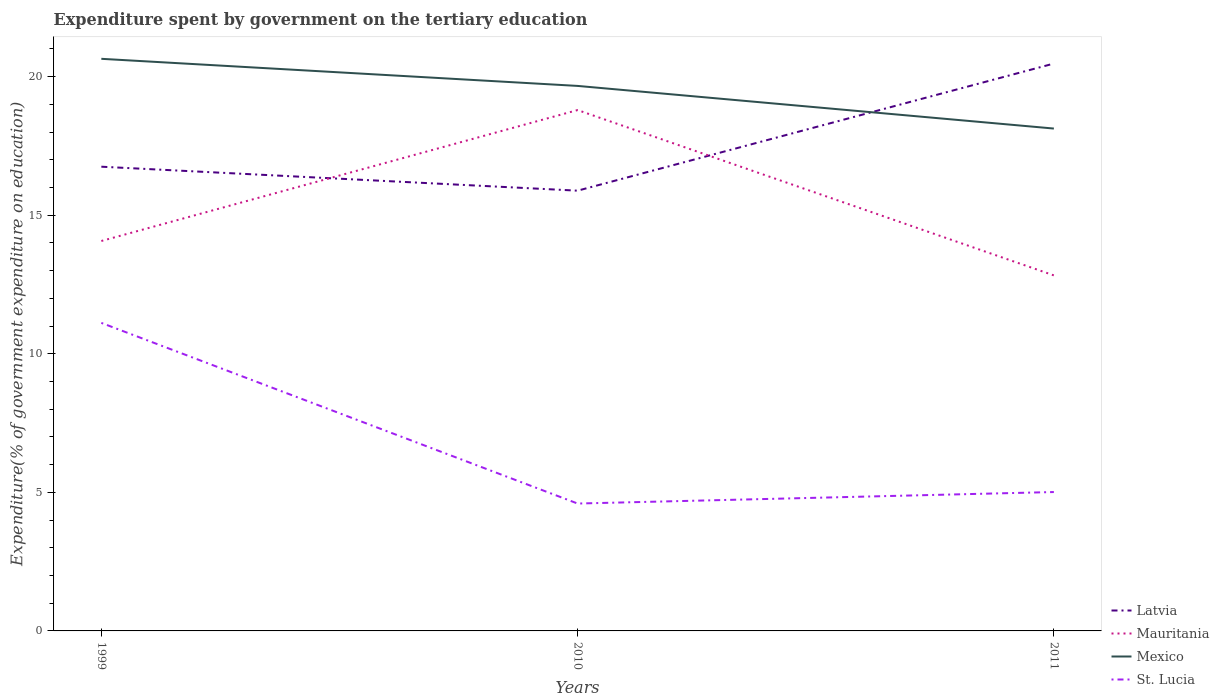Across all years, what is the maximum expenditure spent by government on the tertiary education in Latvia?
Offer a very short reply. 15.88. In which year was the expenditure spent by government on the tertiary education in Latvia maximum?
Make the answer very short. 2010. What is the total expenditure spent by government on the tertiary education in Latvia in the graph?
Provide a short and direct response. 0.86. What is the difference between the highest and the second highest expenditure spent by government on the tertiary education in Mexico?
Your answer should be very brief. 2.52. How many years are there in the graph?
Give a very brief answer. 3. Does the graph contain any zero values?
Your response must be concise. No. Does the graph contain grids?
Your answer should be very brief. No. Where does the legend appear in the graph?
Your response must be concise. Bottom right. How many legend labels are there?
Ensure brevity in your answer.  4. What is the title of the graph?
Your answer should be very brief. Expenditure spent by government on the tertiary education. Does "Sub-Saharan Africa (all income levels)" appear as one of the legend labels in the graph?
Provide a succinct answer. No. What is the label or title of the Y-axis?
Offer a terse response. Expenditure(% of government expenditure on education). What is the Expenditure(% of government expenditure on education) in Latvia in 1999?
Offer a terse response. 16.75. What is the Expenditure(% of government expenditure on education) of Mauritania in 1999?
Your answer should be very brief. 14.07. What is the Expenditure(% of government expenditure on education) of Mexico in 1999?
Your answer should be very brief. 20.64. What is the Expenditure(% of government expenditure on education) in St. Lucia in 1999?
Provide a succinct answer. 11.11. What is the Expenditure(% of government expenditure on education) in Latvia in 2010?
Your answer should be compact. 15.88. What is the Expenditure(% of government expenditure on education) of Mauritania in 2010?
Offer a very short reply. 18.79. What is the Expenditure(% of government expenditure on education) of Mexico in 2010?
Provide a succinct answer. 19.66. What is the Expenditure(% of government expenditure on education) of St. Lucia in 2010?
Give a very brief answer. 4.6. What is the Expenditure(% of government expenditure on education) of Latvia in 2011?
Your answer should be very brief. 20.47. What is the Expenditure(% of government expenditure on education) of Mauritania in 2011?
Make the answer very short. 12.83. What is the Expenditure(% of government expenditure on education) of Mexico in 2011?
Offer a terse response. 18.13. What is the Expenditure(% of government expenditure on education) of St. Lucia in 2011?
Offer a terse response. 5.01. Across all years, what is the maximum Expenditure(% of government expenditure on education) in Latvia?
Keep it short and to the point. 20.47. Across all years, what is the maximum Expenditure(% of government expenditure on education) in Mauritania?
Provide a short and direct response. 18.79. Across all years, what is the maximum Expenditure(% of government expenditure on education) in Mexico?
Offer a terse response. 20.64. Across all years, what is the maximum Expenditure(% of government expenditure on education) of St. Lucia?
Provide a short and direct response. 11.11. Across all years, what is the minimum Expenditure(% of government expenditure on education) of Latvia?
Your answer should be compact. 15.88. Across all years, what is the minimum Expenditure(% of government expenditure on education) in Mauritania?
Provide a short and direct response. 12.83. Across all years, what is the minimum Expenditure(% of government expenditure on education) of Mexico?
Your answer should be very brief. 18.13. Across all years, what is the minimum Expenditure(% of government expenditure on education) in St. Lucia?
Keep it short and to the point. 4.6. What is the total Expenditure(% of government expenditure on education) in Latvia in the graph?
Offer a very short reply. 53.1. What is the total Expenditure(% of government expenditure on education) of Mauritania in the graph?
Ensure brevity in your answer.  45.69. What is the total Expenditure(% of government expenditure on education) of Mexico in the graph?
Your answer should be compact. 58.43. What is the total Expenditure(% of government expenditure on education) in St. Lucia in the graph?
Offer a terse response. 20.72. What is the difference between the Expenditure(% of government expenditure on education) of Latvia in 1999 and that in 2010?
Your response must be concise. 0.86. What is the difference between the Expenditure(% of government expenditure on education) of Mauritania in 1999 and that in 2010?
Offer a terse response. -4.72. What is the difference between the Expenditure(% of government expenditure on education) of Mexico in 1999 and that in 2010?
Your answer should be compact. 0.98. What is the difference between the Expenditure(% of government expenditure on education) in St. Lucia in 1999 and that in 2010?
Provide a succinct answer. 6.52. What is the difference between the Expenditure(% of government expenditure on education) of Latvia in 1999 and that in 2011?
Provide a succinct answer. -3.72. What is the difference between the Expenditure(% of government expenditure on education) in Mauritania in 1999 and that in 2011?
Your answer should be compact. 1.24. What is the difference between the Expenditure(% of government expenditure on education) in Mexico in 1999 and that in 2011?
Make the answer very short. 2.52. What is the difference between the Expenditure(% of government expenditure on education) in St. Lucia in 1999 and that in 2011?
Provide a succinct answer. 6.1. What is the difference between the Expenditure(% of government expenditure on education) of Latvia in 2010 and that in 2011?
Make the answer very short. -4.59. What is the difference between the Expenditure(% of government expenditure on education) of Mauritania in 2010 and that in 2011?
Your response must be concise. 5.96. What is the difference between the Expenditure(% of government expenditure on education) of Mexico in 2010 and that in 2011?
Give a very brief answer. 1.54. What is the difference between the Expenditure(% of government expenditure on education) in St. Lucia in 2010 and that in 2011?
Provide a short and direct response. -0.42. What is the difference between the Expenditure(% of government expenditure on education) in Latvia in 1999 and the Expenditure(% of government expenditure on education) in Mauritania in 2010?
Keep it short and to the point. -2.04. What is the difference between the Expenditure(% of government expenditure on education) in Latvia in 1999 and the Expenditure(% of government expenditure on education) in Mexico in 2010?
Offer a terse response. -2.91. What is the difference between the Expenditure(% of government expenditure on education) of Latvia in 1999 and the Expenditure(% of government expenditure on education) of St. Lucia in 2010?
Offer a very short reply. 12.15. What is the difference between the Expenditure(% of government expenditure on education) in Mauritania in 1999 and the Expenditure(% of government expenditure on education) in Mexico in 2010?
Offer a terse response. -5.59. What is the difference between the Expenditure(% of government expenditure on education) of Mauritania in 1999 and the Expenditure(% of government expenditure on education) of St. Lucia in 2010?
Provide a short and direct response. 9.47. What is the difference between the Expenditure(% of government expenditure on education) in Mexico in 1999 and the Expenditure(% of government expenditure on education) in St. Lucia in 2010?
Provide a short and direct response. 16.05. What is the difference between the Expenditure(% of government expenditure on education) of Latvia in 1999 and the Expenditure(% of government expenditure on education) of Mauritania in 2011?
Provide a succinct answer. 3.92. What is the difference between the Expenditure(% of government expenditure on education) in Latvia in 1999 and the Expenditure(% of government expenditure on education) in Mexico in 2011?
Provide a short and direct response. -1.38. What is the difference between the Expenditure(% of government expenditure on education) in Latvia in 1999 and the Expenditure(% of government expenditure on education) in St. Lucia in 2011?
Make the answer very short. 11.74. What is the difference between the Expenditure(% of government expenditure on education) in Mauritania in 1999 and the Expenditure(% of government expenditure on education) in Mexico in 2011?
Your response must be concise. -4.06. What is the difference between the Expenditure(% of government expenditure on education) of Mauritania in 1999 and the Expenditure(% of government expenditure on education) of St. Lucia in 2011?
Ensure brevity in your answer.  9.06. What is the difference between the Expenditure(% of government expenditure on education) of Mexico in 1999 and the Expenditure(% of government expenditure on education) of St. Lucia in 2011?
Give a very brief answer. 15.63. What is the difference between the Expenditure(% of government expenditure on education) of Latvia in 2010 and the Expenditure(% of government expenditure on education) of Mauritania in 2011?
Your response must be concise. 3.06. What is the difference between the Expenditure(% of government expenditure on education) in Latvia in 2010 and the Expenditure(% of government expenditure on education) in Mexico in 2011?
Your answer should be very brief. -2.24. What is the difference between the Expenditure(% of government expenditure on education) in Latvia in 2010 and the Expenditure(% of government expenditure on education) in St. Lucia in 2011?
Give a very brief answer. 10.87. What is the difference between the Expenditure(% of government expenditure on education) in Mauritania in 2010 and the Expenditure(% of government expenditure on education) in Mexico in 2011?
Your response must be concise. 0.67. What is the difference between the Expenditure(% of government expenditure on education) of Mauritania in 2010 and the Expenditure(% of government expenditure on education) of St. Lucia in 2011?
Offer a terse response. 13.78. What is the difference between the Expenditure(% of government expenditure on education) in Mexico in 2010 and the Expenditure(% of government expenditure on education) in St. Lucia in 2011?
Ensure brevity in your answer.  14.65. What is the average Expenditure(% of government expenditure on education) in Latvia per year?
Keep it short and to the point. 17.7. What is the average Expenditure(% of government expenditure on education) in Mauritania per year?
Your answer should be compact. 15.23. What is the average Expenditure(% of government expenditure on education) in Mexico per year?
Make the answer very short. 19.48. What is the average Expenditure(% of government expenditure on education) in St. Lucia per year?
Keep it short and to the point. 6.91. In the year 1999, what is the difference between the Expenditure(% of government expenditure on education) of Latvia and Expenditure(% of government expenditure on education) of Mauritania?
Offer a very short reply. 2.68. In the year 1999, what is the difference between the Expenditure(% of government expenditure on education) in Latvia and Expenditure(% of government expenditure on education) in Mexico?
Offer a terse response. -3.89. In the year 1999, what is the difference between the Expenditure(% of government expenditure on education) of Latvia and Expenditure(% of government expenditure on education) of St. Lucia?
Your answer should be compact. 5.64. In the year 1999, what is the difference between the Expenditure(% of government expenditure on education) in Mauritania and Expenditure(% of government expenditure on education) in Mexico?
Provide a short and direct response. -6.57. In the year 1999, what is the difference between the Expenditure(% of government expenditure on education) in Mauritania and Expenditure(% of government expenditure on education) in St. Lucia?
Your answer should be very brief. 2.95. In the year 1999, what is the difference between the Expenditure(% of government expenditure on education) of Mexico and Expenditure(% of government expenditure on education) of St. Lucia?
Make the answer very short. 9.53. In the year 2010, what is the difference between the Expenditure(% of government expenditure on education) in Latvia and Expenditure(% of government expenditure on education) in Mauritania?
Provide a succinct answer. -2.91. In the year 2010, what is the difference between the Expenditure(% of government expenditure on education) of Latvia and Expenditure(% of government expenditure on education) of Mexico?
Make the answer very short. -3.78. In the year 2010, what is the difference between the Expenditure(% of government expenditure on education) in Latvia and Expenditure(% of government expenditure on education) in St. Lucia?
Your response must be concise. 11.29. In the year 2010, what is the difference between the Expenditure(% of government expenditure on education) in Mauritania and Expenditure(% of government expenditure on education) in Mexico?
Give a very brief answer. -0.87. In the year 2010, what is the difference between the Expenditure(% of government expenditure on education) in Mauritania and Expenditure(% of government expenditure on education) in St. Lucia?
Your answer should be very brief. 14.2. In the year 2010, what is the difference between the Expenditure(% of government expenditure on education) of Mexico and Expenditure(% of government expenditure on education) of St. Lucia?
Give a very brief answer. 15.07. In the year 2011, what is the difference between the Expenditure(% of government expenditure on education) of Latvia and Expenditure(% of government expenditure on education) of Mauritania?
Your answer should be compact. 7.64. In the year 2011, what is the difference between the Expenditure(% of government expenditure on education) of Latvia and Expenditure(% of government expenditure on education) of Mexico?
Make the answer very short. 2.35. In the year 2011, what is the difference between the Expenditure(% of government expenditure on education) in Latvia and Expenditure(% of government expenditure on education) in St. Lucia?
Give a very brief answer. 15.46. In the year 2011, what is the difference between the Expenditure(% of government expenditure on education) in Mauritania and Expenditure(% of government expenditure on education) in Mexico?
Keep it short and to the point. -5.3. In the year 2011, what is the difference between the Expenditure(% of government expenditure on education) of Mauritania and Expenditure(% of government expenditure on education) of St. Lucia?
Offer a very short reply. 7.82. In the year 2011, what is the difference between the Expenditure(% of government expenditure on education) of Mexico and Expenditure(% of government expenditure on education) of St. Lucia?
Your response must be concise. 13.11. What is the ratio of the Expenditure(% of government expenditure on education) in Latvia in 1999 to that in 2010?
Ensure brevity in your answer.  1.05. What is the ratio of the Expenditure(% of government expenditure on education) of Mauritania in 1999 to that in 2010?
Your response must be concise. 0.75. What is the ratio of the Expenditure(% of government expenditure on education) in Mexico in 1999 to that in 2010?
Offer a very short reply. 1.05. What is the ratio of the Expenditure(% of government expenditure on education) of St. Lucia in 1999 to that in 2010?
Provide a succinct answer. 2.42. What is the ratio of the Expenditure(% of government expenditure on education) of Latvia in 1999 to that in 2011?
Give a very brief answer. 0.82. What is the ratio of the Expenditure(% of government expenditure on education) of Mauritania in 1999 to that in 2011?
Provide a succinct answer. 1.1. What is the ratio of the Expenditure(% of government expenditure on education) in Mexico in 1999 to that in 2011?
Provide a succinct answer. 1.14. What is the ratio of the Expenditure(% of government expenditure on education) of St. Lucia in 1999 to that in 2011?
Offer a terse response. 2.22. What is the ratio of the Expenditure(% of government expenditure on education) of Latvia in 2010 to that in 2011?
Give a very brief answer. 0.78. What is the ratio of the Expenditure(% of government expenditure on education) of Mauritania in 2010 to that in 2011?
Ensure brevity in your answer.  1.47. What is the ratio of the Expenditure(% of government expenditure on education) of Mexico in 2010 to that in 2011?
Offer a terse response. 1.08. What is the ratio of the Expenditure(% of government expenditure on education) in St. Lucia in 2010 to that in 2011?
Your response must be concise. 0.92. What is the difference between the highest and the second highest Expenditure(% of government expenditure on education) of Latvia?
Your response must be concise. 3.72. What is the difference between the highest and the second highest Expenditure(% of government expenditure on education) of Mauritania?
Provide a succinct answer. 4.72. What is the difference between the highest and the second highest Expenditure(% of government expenditure on education) of Mexico?
Offer a very short reply. 0.98. What is the difference between the highest and the second highest Expenditure(% of government expenditure on education) in St. Lucia?
Your response must be concise. 6.1. What is the difference between the highest and the lowest Expenditure(% of government expenditure on education) in Latvia?
Provide a short and direct response. 4.59. What is the difference between the highest and the lowest Expenditure(% of government expenditure on education) in Mauritania?
Your answer should be very brief. 5.96. What is the difference between the highest and the lowest Expenditure(% of government expenditure on education) of Mexico?
Your answer should be compact. 2.52. What is the difference between the highest and the lowest Expenditure(% of government expenditure on education) of St. Lucia?
Keep it short and to the point. 6.52. 